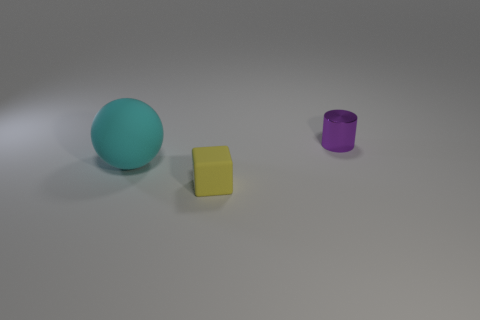There is a matte thing that is in front of the big cyan object left of the small object that is to the left of the purple thing; what size is it?
Offer a terse response. Small. What is the color of the object that is both on the right side of the large matte object and left of the metal cylinder?
Give a very brief answer. Yellow. Does the cylinder have the same size as the rubber thing that is to the right of the big cyan sphere?
Ensure brevity in your answer.  Yes. Are there any other things that are the same shape as the big rubber thing?
Make the answer very short. No. Do the cylinder and the rubber block have the same size?
Your response must be concise. Yes. What number of other objects are the same size as the cyan object?
Make the answer very short. 0. What number of objects are tiny objects left of the small purple shiny cylinder or rubber things in front of the cyan thing?
Your answer should be compact. 1. What shape is the metal thing that is the same size as the yellow matte block?
Your response must be concise. Cylinder. The yellow cube that is the same material as the cyan thing is what size?
Make the answer very short. Small. Does the small yellow object have the same shape as the big thing?
Your answer should be very brief. No. 